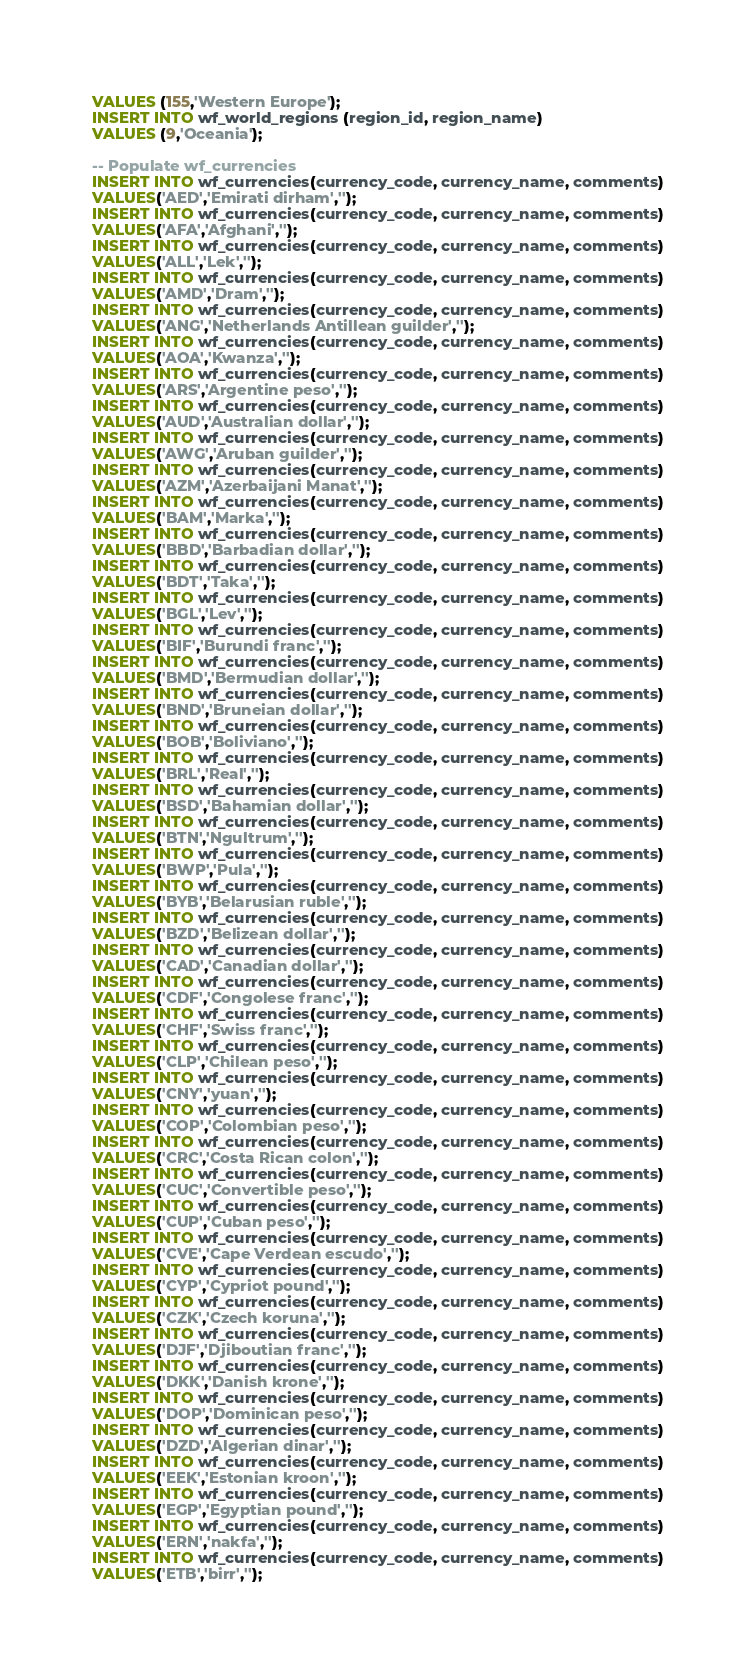<code> <loc_0><loc_0><loc_500><loc_500><_SQL_>VALUES (155,'Western Europe');
INSERT INTO wf_world_regions (region_id, region_name)
VALUES (9,'Oceania');

-- Populate wf_currencies
INSERT INTO wf_currencies(currency_code, currency_name, comments)
VALUES('AED','Emirati dirham','');
INSERT INTO wf_currencies(currency_code, currency_name, comments)
VALUES('AFA','Afghani','');
INSERT INTO wf_currencies(currency_code, currency_name, comments)
VALUES('ALL','Lek','');
INSERT INTO wf_currencies(currency_code, currency_name, comments)
VALUES('AMD','Dram','');
INSERT INTO wf_currencies(currency_code, currency_name, comments)
VALUES('ANG','Netherlands Antillean guilder','');
INSERT INTO wf_currencies(currency_code, currency_name, comments)
VALUES('AOA','Kwanza','');
INSERT INTO wf_currencies(currency_code, currency_name, comments)
VALUES('ARS','Argentine peso','');
INSERT INTO wf_currencies(currency_code, currency_name, comments)
VALUES('AUD','Australian dollar','');
INSERT INTO wf_currencies(currency_code, currency_name, comments)
VALUES('AWG','Aruban guilder','');
INSERT INTO wf_currencies(currency_code, currency_name, comments)
VALUES('AZM','Azerbaijani Manat','');
INSERT INTO wf_currencies(currency_code, currency_name, comments)
VALUES('BAM','Marka','');
INSERT INTO wf_currencies(currency_code, currency_name, comments)
VALUES('BBD','Barbadian dollar','');
INSERT INTO wf_currencies(currency_code, currency_name, comments)
VALUES('BDT','Taka','');
INSERT INTO wf_currencies(currency_code, currency_name, comments)
VALUES('BGL','Lev','');
INSERT INTO wf_currencies(currency_code, currency_name, comments)
VALUES('BIF','Burundi franc','');
INSERT INTO wf_currencies(currency_code, currency_name, comments)
VALUES('BMD','Bermudian dollar','');
INSERT INTO wf_currencies(currency_code, currency_name, comments)
VALUES('BND','Bruneian dollar','');
INSERT INTO wf_currencies(currency_code, currency_name, comments)
VALUES('BOB','Boliviano','');
INSERT INTO wf_currencies(currency_code, currency_name, comments)
VALUES('BRL','Real','');
INSERT INTO wf_currencies(currency_code, currency_name, comments)
VALUES('BSD','Bahamian dollar','');
INSERT INTO wf_currencies(currency_code, currency_name, comments)
VALUES('BTN','Ngultrum','');
INSERT INTO wf_currencies(currency_code, currency_name, comments)
VALUES('BWP','Pula','');
INSERT INTO wf_currencies(currency_code, currency_name, comments)
VALUES('BYB','Belarusian ruble','');
INSERT INTO wf_currencies(currency_code, currency_name, comments)
VALUES('BZD','Belizean dollar','');
INSERT INTO wf_currencies(currency_code, currency_name, comments)
VALUES('CAD','Canadian dollar','');
INSERT INTO wf_currencies(currency_code, currency_name, comments)
VALUES('CDF','Congolese franc','');
INSERT INTO wf_currencies(currency_code, currency_name, comments)
VALUES('CHF','Swiss franc','');
INSERT INTO wf_currencies(currency_code, currency_name, comments)
VALUES('CLP','Chilean peso','');
INSERT INTO wf_currencies(currency_code, currency_name, comments)
VALUES('CNY','yuan','');
INSERT INTO wf_currencies(currency_code, currency_name, comments)
VALUES('COP','Colombian peso','');
INSERT INTO wf_currencies(currency_code, currency_name, comments)
VALUES('CRC','Costa Rican colon','');
INSERT INTO wf_currencies(currency_code, currency_name, comments)
VALUES('CUC','Convertible peso','');
INSERT INTO wf_currencies(currency_code, currency_name, comments)
VALUES('CUP','Cuban peso','');
INSERT INTO wf_currencies(currency_code, currency_name, comments)
VALUES('CVE','Cape Verdean escudo','');
INSERT INTO wf_currencies(currency_code, currency_name, comments)
VALUES('CYP','Cypriot pound','');
INSERT INTO wf_currencies(currency_code, currency_name, comments)
VALUES('CZK','Czech koruna','');
INSERT INTO wf_currencies(currency_code, currency_name, comments)
VALUES('DJF','Djiboutian franc','');
INSERT INTO wf_currencies(currency_code, currency_name, comments)
VALUES('DKK','Danish krone','');
INSERT INTO wf_currencies(currency_code, currency_name, comments)
VALUES('DOP','Dominican peso','');
INSERT INTO wf_currencies(currency_code, currency_name, comments)
VALUES('DZD','Algerian dinar','');
INSERT INTO wf_currencies(currency_code, currency_name, comments)
VALUES('EEK','Estonian kroon','');
INSERT INTO wf_currencies(currency_code, currency_name, comments)
VALUES('EGP','Egyptian pound','');
INSERT INTO wf_currencies(currency_code, currency_name, comments)
VALUES('ERN','nakfa','');
INSERT INTO wf_currencies(currency_code, currency_name, comments)
VALUES('ETB','birr','');</code> 